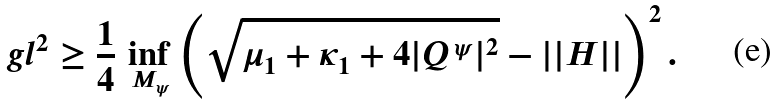Convert formula to latex. <formula><loc_0><loc_0><loc_500><loc_500>\ g l ^ { 2 } \geq \frac { 1 } { 4 } \, \inf _ { M _ { \psi } } \left ( \sqrt { \mu _ { 1 } + \kappa _ { 1 } + 4 | Q ^ { \, \psi } | ^ { 2 } } - | | H | | \right ) ^ { 2 } .</formula> 